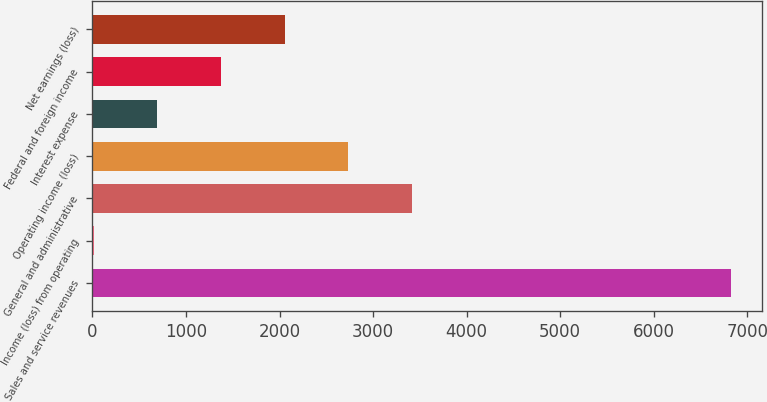<chart> <loc_0><loc_0><loc_500><loc_500><bar_chart><fcel>Sales and service revenues<fcel>Income (loss) from operating<fcel>General and administrative<fcel>Operating income (loss)<fcel>Interest expense<fcel>Federal and foreign income<fcel>Net earnings (loss)<nl><fcel>6820<fcel>14<fcel>3417<fcel>2736.4<fcel>694.6<fcel>1375.2<fcel>2055.8<nl></chart> 